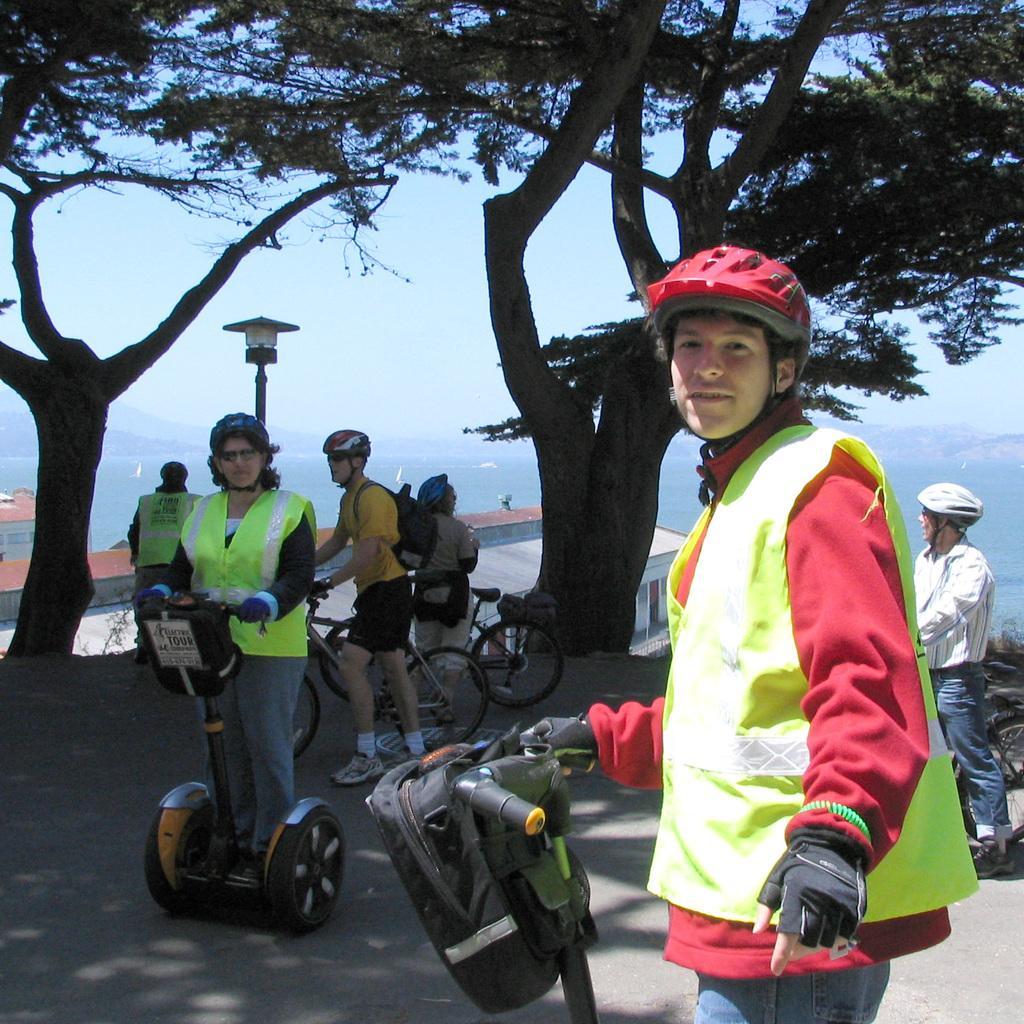Can you describe this image briefly? In this people standing on the set ways, people standing on the road by holding bicycles, street pole, street light, trees, buildings, hills and sky. 